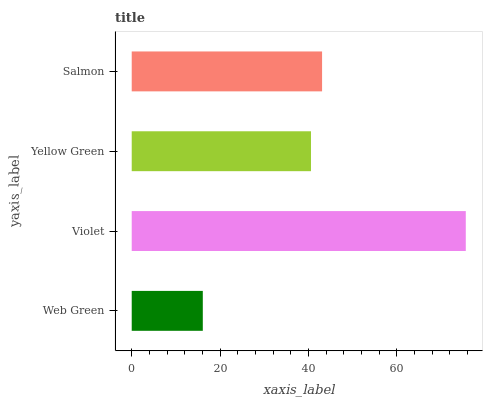Is Web Green the minimum?
Answer yes or no. Yes. Is Violet the maximum?
Answer yes or no. Yes. Is Yellow Green the minimum?
Answer yes or no. No. Is Yellow Green the maximum?
Answer yes or no. No. Is Violet greater than Yellow Green?
Answer yes or no. Yes. Is Yellow Green less than Violet?
Answer yes or no. Yes. Is Yellow Green greater than Violet?
Answer yes or no. No. Is Violet less than Yellow Green?
Answer yes or no. No. Is Salmon the high median?
Answer yes or no. Yes. Is Yellow Green the low median?
Answer yes or no. Yes. Is Web Green the high median?
Answer yes or no. No. Is Violet the low median?
Answer yes or no. No. 